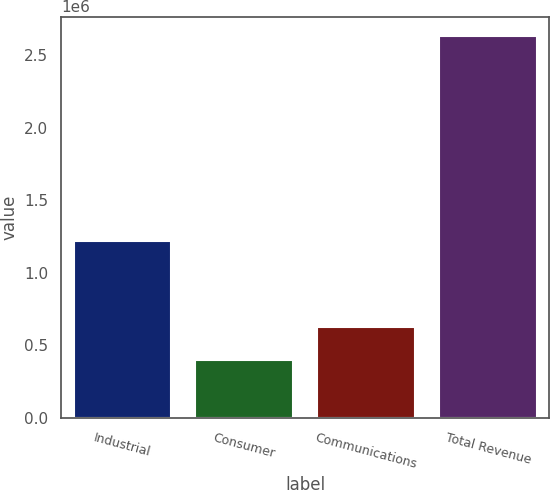Convert chart to OTSL. <chart><loc_0><loc_0><loc_500><loc_500><bar_chart><fcel>Industrial<fcel>Consumer<fcel>Communications<fcel>Total Revenue<nl><fcel>1.22014e+06<fcel>401368<fcel>624600<fcel>2.63369e+06<nl></chart> 